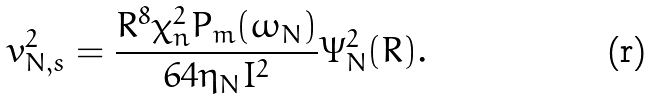<formula> <loc_0><loc_0><loc_500><loc_500>v _ { N , s } ^ { 2 } = \frac { R ^ { 8 } \chi _ { n } ^ { 2 } P _ { m } ( \omega _ { N } ) } { 6 4 \eta _ { N } I ^ { 2 } } \Psi _ { N } ^ { 2 } ( R ) .</formula> 